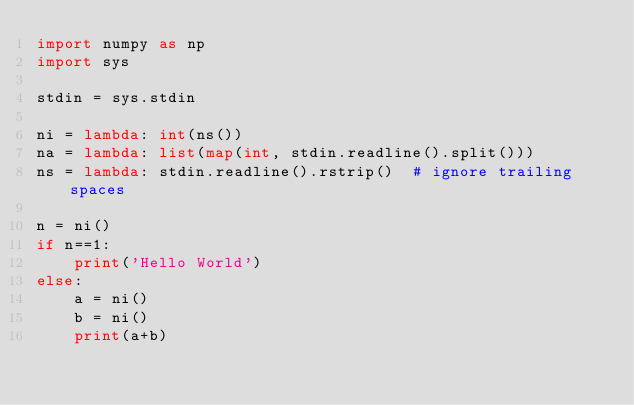Convert code to text. <code><loc_0><loc_0><loc_500><loc_500><_Python_>import numpy as np
import sys
 
stdin = sys.stdin
 
ni = lambda: int(ns())
na = lambda: list(map(int, stdin.readline().split()))
ns = lambda: stdin.readline().rstrip()  # ignore trailing spaces
 
n = ni()
if n==1:
    print('Hello World')
else:
    a = ni()
    b = ni()
    print(a+b)</code> 